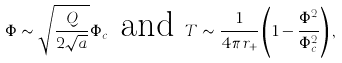Convert formula to latex. <formula><loc_0><loc_0><loc_500><loc_500>\Phi \sim \sqrt { \frac { Q } { 2 \sqrt { a } } } \Phi _ { c } \text { and } T \sim \frac { 1 } { 4 \pi r _ { + } } \left ( 1 - \frac { \Phi ^ { 2 } } { \Phi _ { c } ^ { 2 } } \right ) ,</formula> 